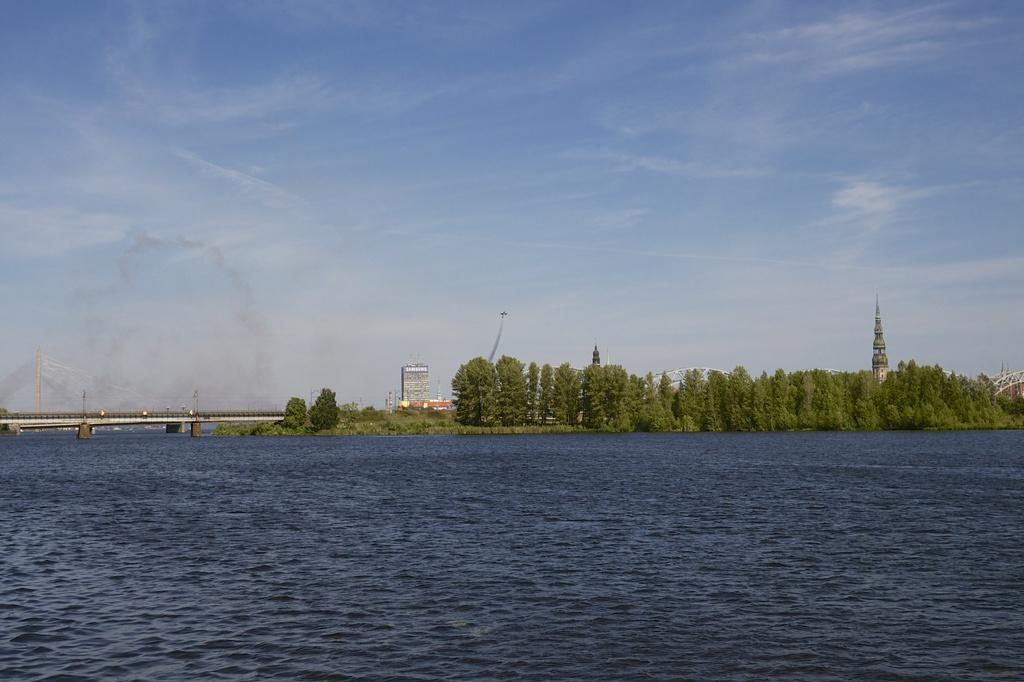What is the primary element visible in the image? There is water in the image. What type of natural vegetation can be seen in the image? There are trees in the image. What structure is present in the image that allows people to cross the water? There is a bridge in the image. What type of man-made structures are visible in the image? There are buildings in the image. What can be seen in the background of the image? The sky is visible in the background of the image. What type of zinc is used to construct the bridge in the image? There is no mention of zinc or any specific construction material used for the bridge in the image. How many kittens can be seen playing near the water in the image? There are no kittens present in the image. 